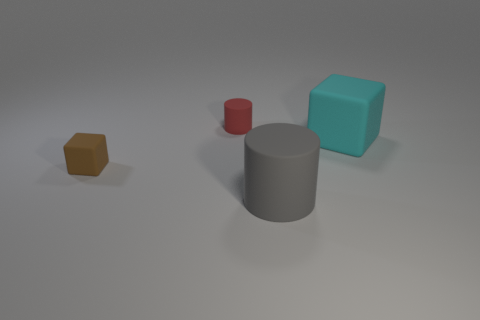Add 2 big purple matte blocks. How many objects exist? 6 Subtract 0 purple cylinders. How many objects are left? 4 Subtract all small blue metal blocks. Subtract all small objects. How many objects are left? 2 Add 3 tiny matte objects. How many tiny matte objects are left? 5 Add 4 gray matte cylinders. How many gray matte cylinders exist? 5 